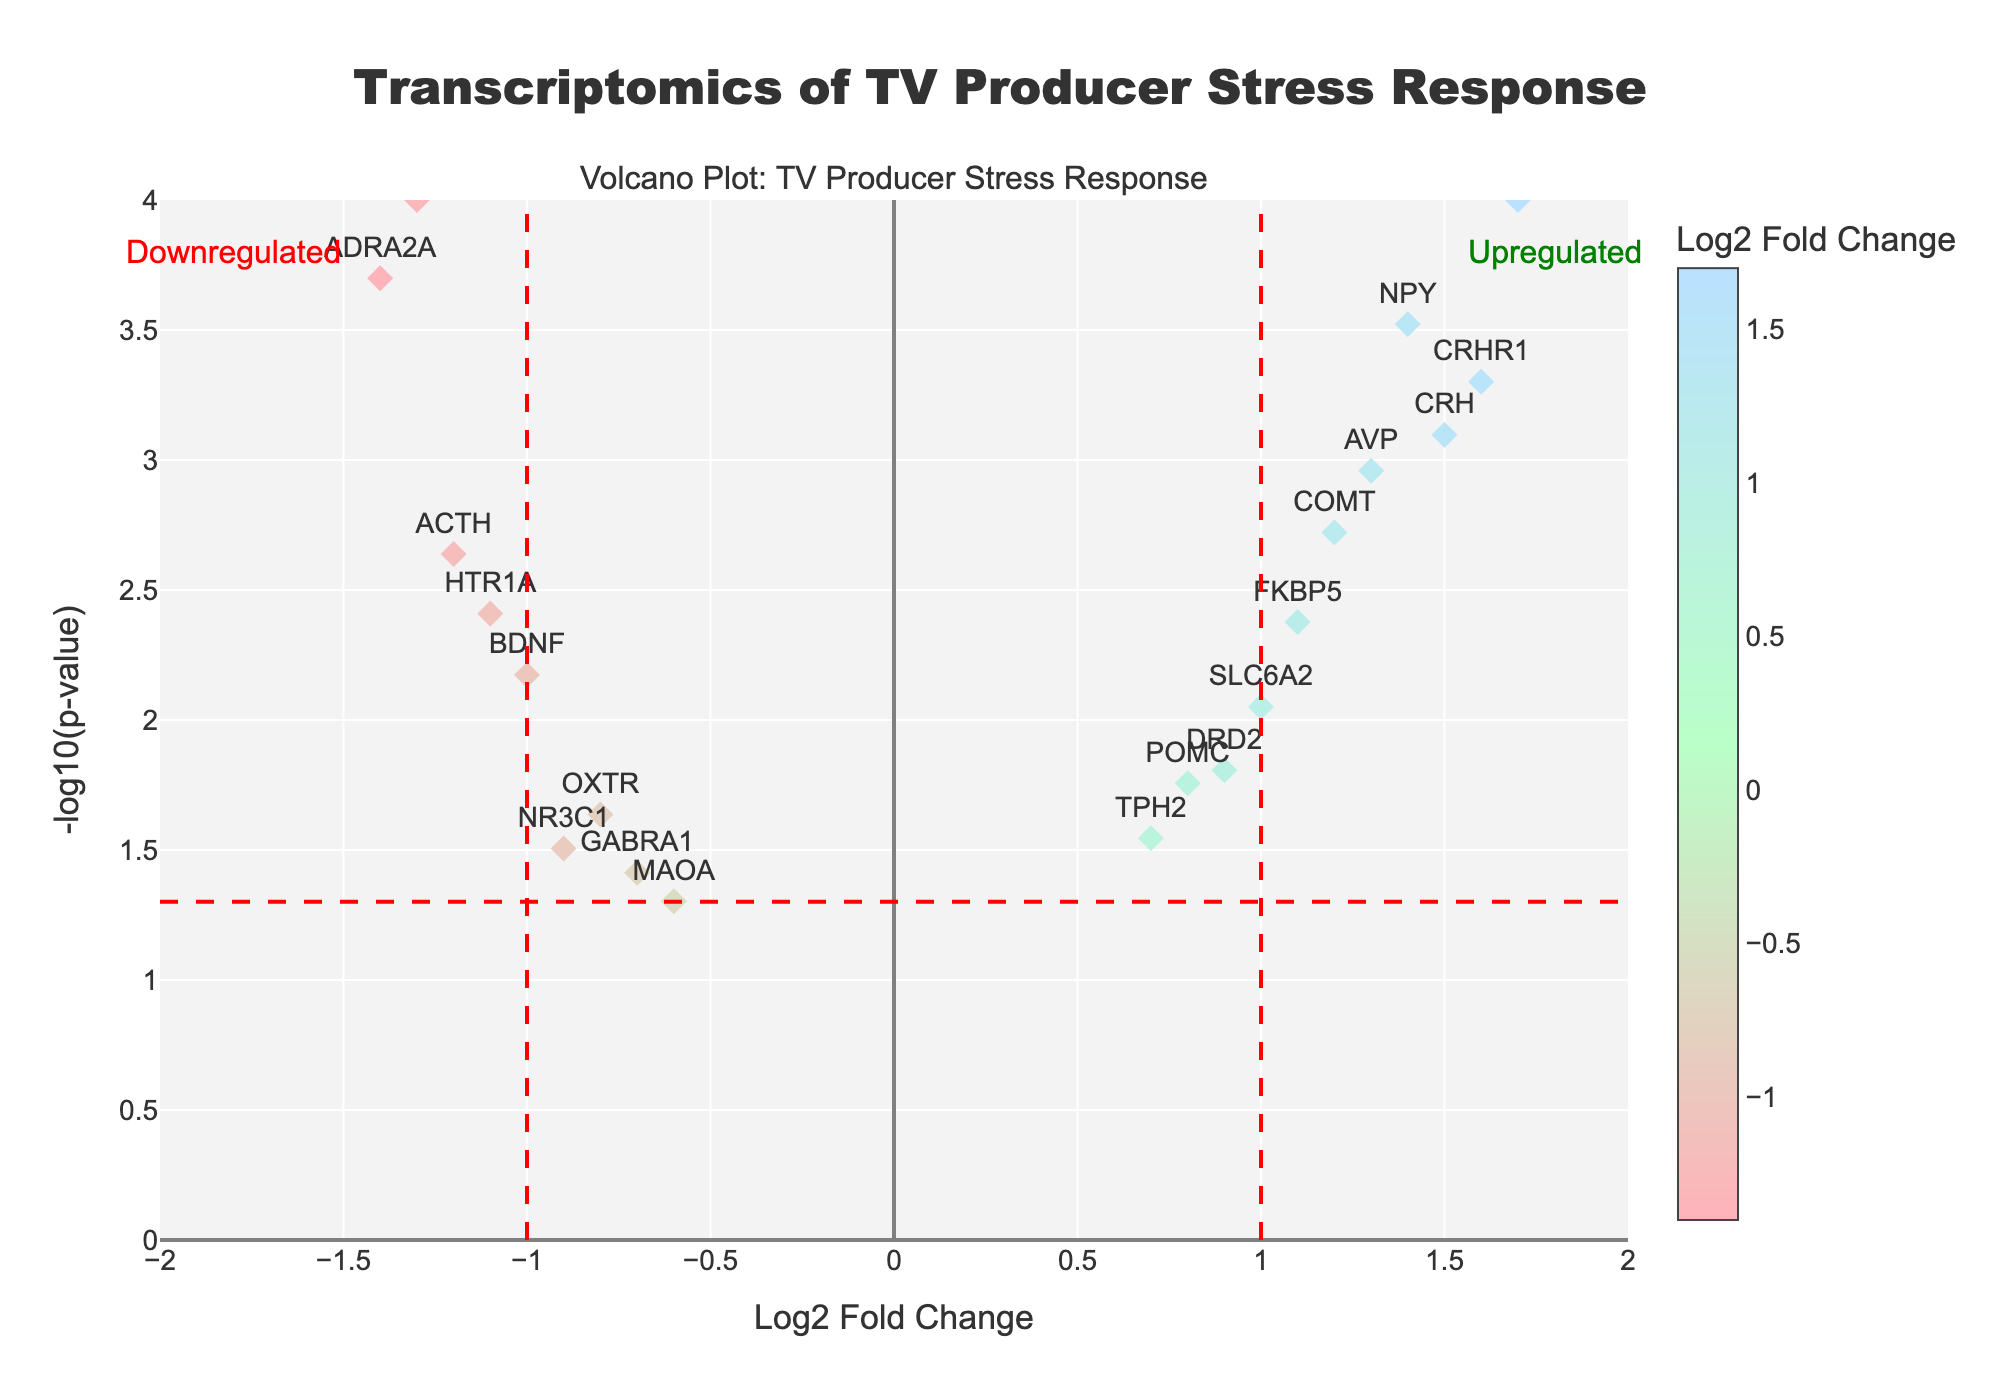What is the title of the figure? The title is shown at the top of the figure.
Answer: Transcriptomics of TV Producer Stress Response How many genes show a Log2 Fold Change greater than 1? Look at the points to the right side of the vertical '1' line. Count the number of genes.
Answer: 7 Which gene shows the most significant increase in expression level? Identify the gene with the highest Log2 Fold Change value.
Answer: IL6 What axis represents the -log10 p-value? The y-axis is labeled with -log10(p-value), indicating p-values are represented on this axis.
Answer: y-axis Which genes are significantly downregulated? Focus on genes with a Log2 Fold Change less than -1 and a p-value less than 0.05. These appear on the bottom left side of the plot and below the horizontal threshold line.
Answer: ADRA2A, ACTH, SLC6A4, HTR1A What is the Log2 Fold Change of the gene COMT? Look for the labeled point 'COMT' and check its position on the x-axis.
Answer: 1.2 How many genes are considered upregulated with a p-value less than 0.01? Count the genes on the right side of the plot that lie above the horizontal threshold line indicating a p-value of 0.01.
Answer: 5 Which gene has the lowest p-value, and what does it signify? The gene with the highest -log10 p-value indicates the lowest p-value; check the topmost point in the figure. This indicates the most statistically significant change.
Answer: SLC6A4; very significant What color represents the highest Log2 Fold Change values in this plot? Identify the color on the color scale/bar associated with the highest Log2 Fold Change values.
Answer: Light blue 